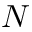<formula> <loc_0><loc_0><loc_500><loc_500>N</formula> 